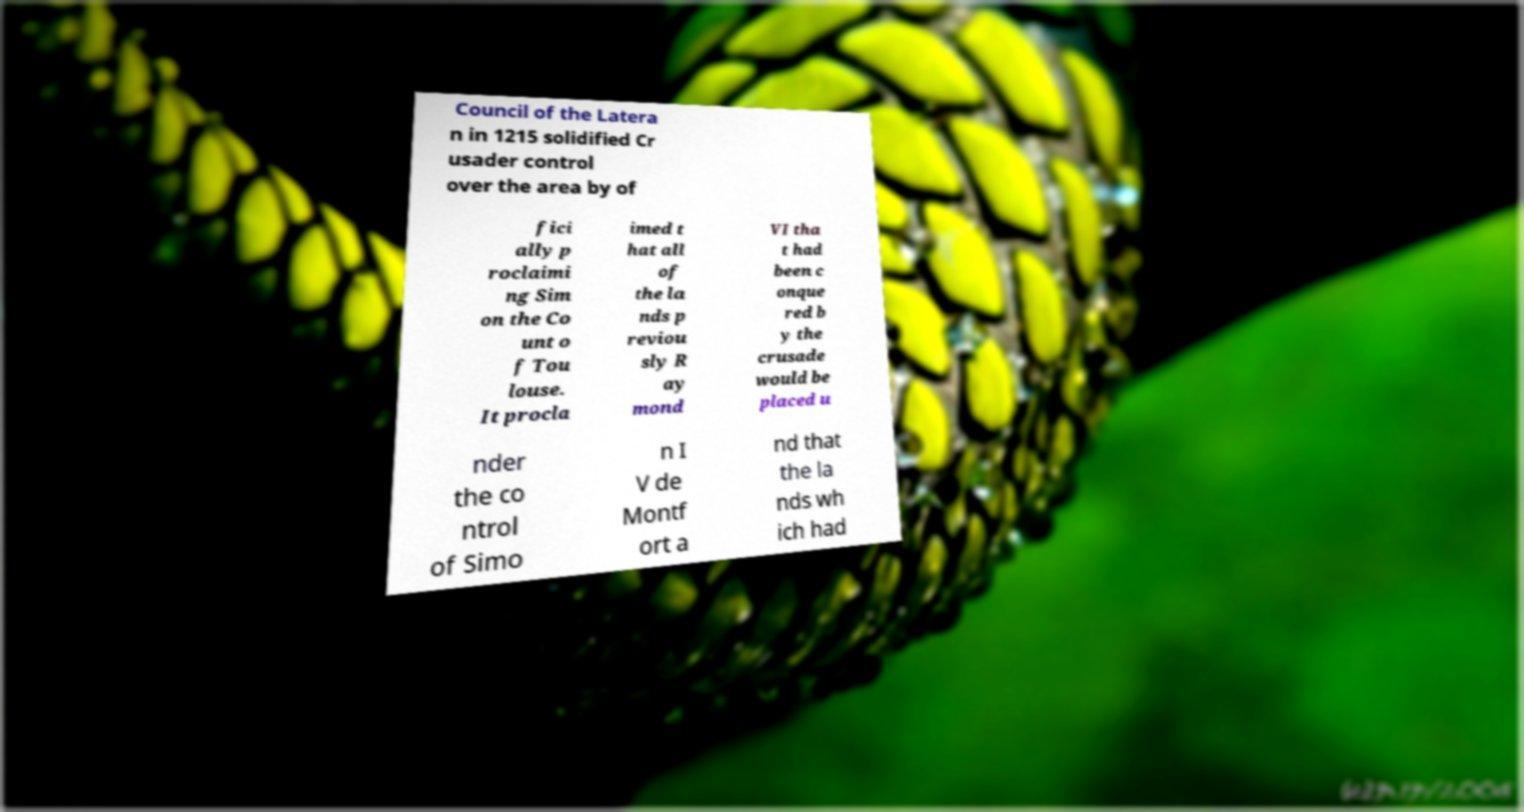I need the written content from this picture converted into text. Can you do that? Council of the Latera n in 1215 solidified Cr usader control over the area by of fici ally p roclaimi ng Sim on the Co unt o f Tou louse. It procla imed t hat all of the la nds p reviou sly R ay mond VI tha t had been c onque red b y the crusade would be placed u nder the co ntrol of Simo n I V de Montf ort a nd that the la nds wh ich had 